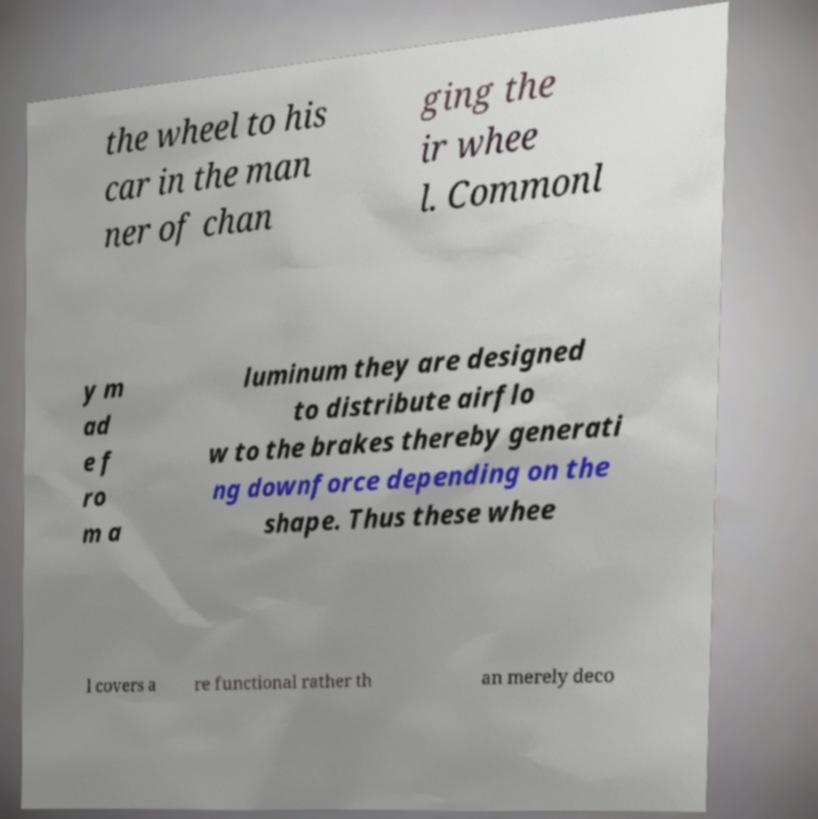I need the written content from this picture converted into text. Can you do that? the wheel to his car in the man ner of chan ging the ir whee l. Commonl y m ad e f ro m a luminum they are designed to distribute airflo w to the brakes thereby generati ng downforce depending on the shape. Thus these whee l covers a re functional rather th an merely deco 